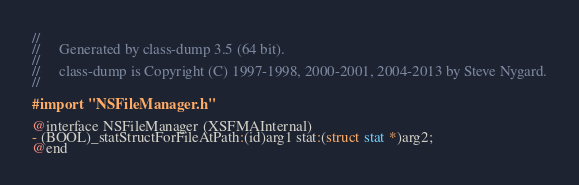<code> <loc_0><loc_0><loc_500><loc_500><_C_>//
//     Generated by class-dump 3.5 (64 bit).
//
//     class-dump is Copyright (C) 1997-1998, 2000-2001, 2004-2013 by Steve Nygard.
//

#import "NSFileManager.h"

@interface NSFileManager (XSFMAInternal)
- (BOOL)_statStructForFileAtPath:(id)arg1 stat:(struct stat *)arg2;
@end

</code> 